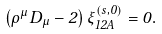Convert formula to latex. <formula><loc_0><loc_0><loc_500><loc_500>\left ( \rho ^ { \mu } D _ { \mu } - 2 \right ) \xi _ { 1 2 A } ^ { ( s , 0 ) } = 0 .</formula> 